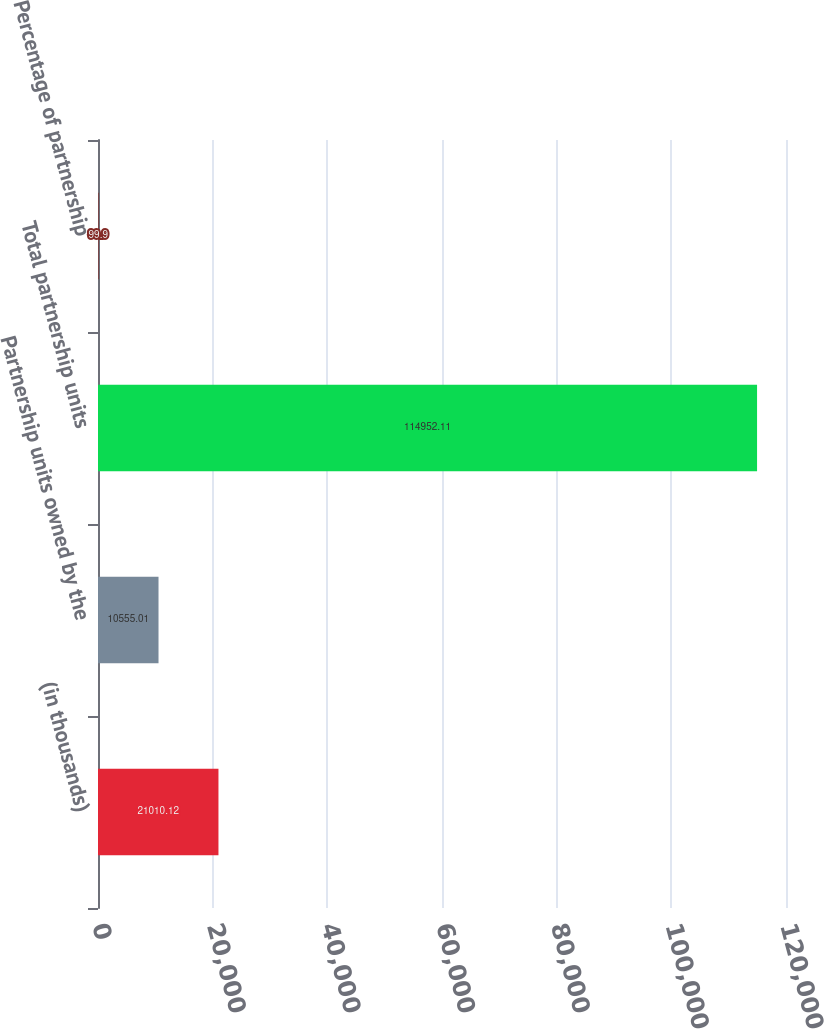<chart> <loc_0><loc_0><loc_500><loc_500><bar_chart><fcel>(in thousands)<fcel>Partnership units owned by the<fcel>Total partnership units<fcel>Percentage of partnership<nl><fcel>21010.1<fcel>10555<fcel>114952<fcel>99.9<nl></chart> 